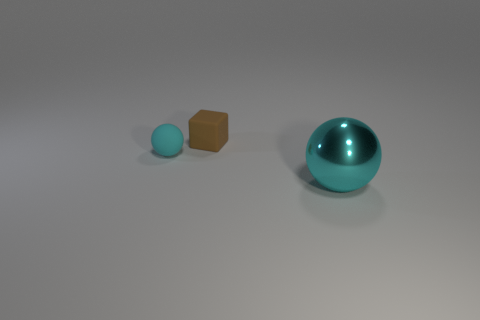There is a matte object that is on the left side of the small object on the right side of the small ball; what number of cyan matte things are in front of it?
Offer a terse response. 0. Is the number of cyan metallic things that are to the left of the tiny cyan object the same as the number of rubber spheres?
Your answer should be very brief. No. How many spheres are small cyan matte things or small brown rubber things?
Offer a very short reply. 1. Is the small rubber sphere the same color as the large object?
Your response must be concise. Yes. Are there an equal number of large metal spheres right of the large cyan sphere and brown objects left of the small ball?
Your answer should be compact. Yes. What color is the small matte block?
Offer a very short reply. Brown. What number of objects are either objects that are in front of the tiny rubber cube or big objects?
Your answer should be compact. 2. Does the sphere that is to the left of the large cyan thing have the same size as the matte object that is behind the cyan matte sphere?
Ensure brevity in your answer.  Yes. Is there any other thing that is made of the same material as the big cyan ball?
Make the answer very short. No. How many objects are cyan balls that are on the right side of the small brown block or cyan spheres that are right of the brown thing?
Give a very brief answer. 1. 